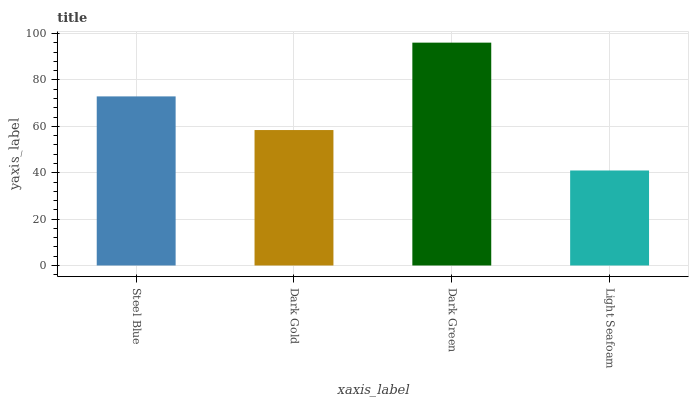Is Light Seafoam the minimum?
Answer yes or no. Yes. Is Dark Green the maximum?
Answer yes or no. Yes. Is Dark Gold the minimum?
Answer yes or no. No. Is Dark Gold the maximum?
Answer yes or no. No. Is Steel Blue greater than Dark Gold?
Answer yes or no. Yes. Is Dark Gold less than Steel Blue?
Answer yes or no. Yes. Is Dark Gold greater than Steel Blue?
Answer yes or no. No. Is Steel Blue less than Dark Gold?
Answer yes or no. No. Is Steel Blue the high median?
Answer yes or no. Yes. Is Dark Gold the low median?
Answer yes or no. Yes. Is Light Seafoam the high median?
Answer yes or no. No. Is Dark Green the low median?
Answer yes or no. No. 